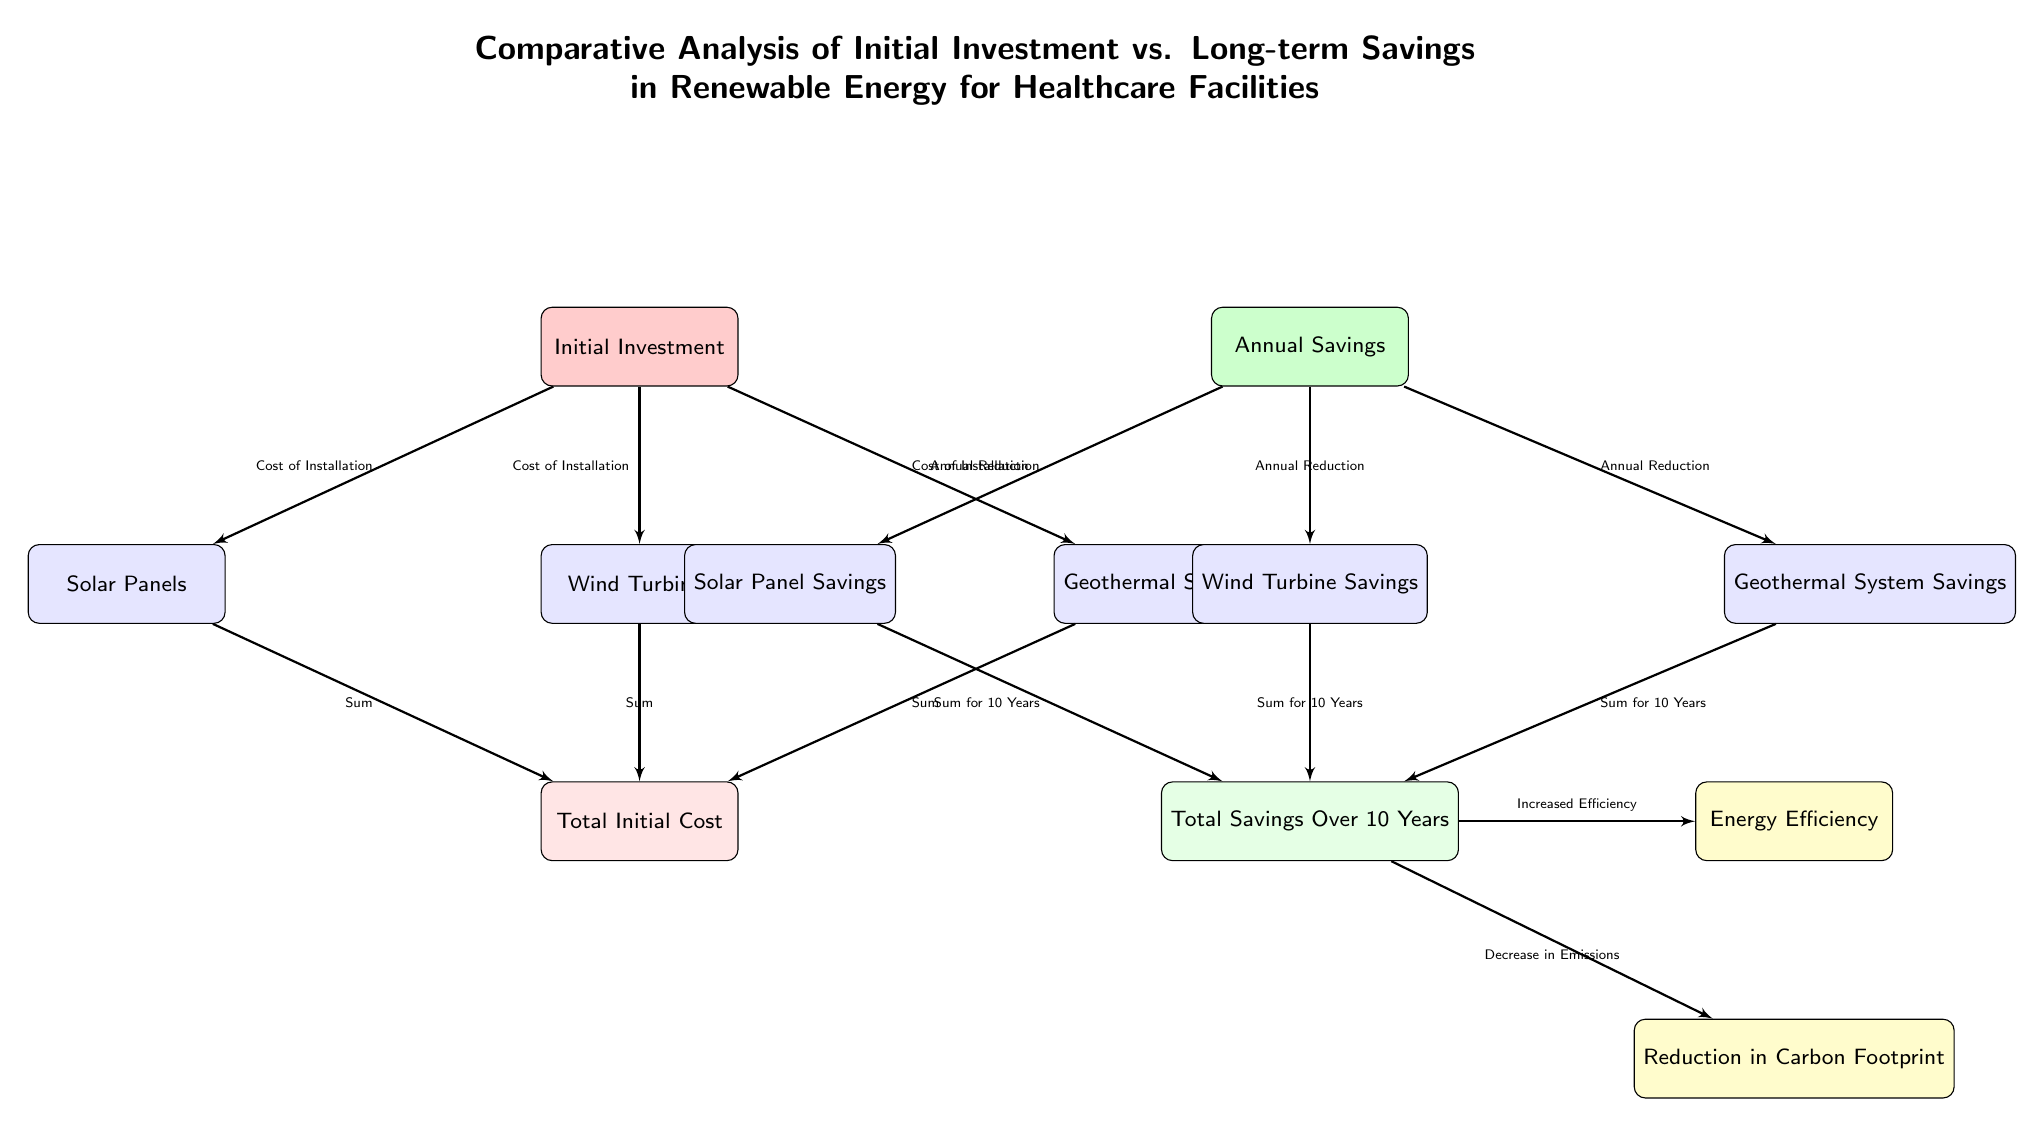What is the purpose of the diagram? The diagram presents a comparative analysis highlighting the initial investment versus long-term savings associated with renewable energy systems in healthcare facilities. It showcases different renewable energy sources and their financial impacts over a decade.
Answer: Comparative analysis of initial investment vs. long-term savings How many types of renewable energy systems are shown? The diagram displays three types of renewable energy systems: Solar Panels, Wind Turbines, and Geothermal Systems, which are visually represented below the Initial Investment node.
Answer: Three What color represents Annual Savings in the diagram? The Annual Savings section is filled with green, indicating the financial benefits gained over time from investing in renewable energy systems.
Answer: Green What does the arrow from Total Savings Over 10 Years point to? The arrow from Total Savings Over 10 Years points to two outcomes: Energy Efficiency and Reduction in Carbon Footprint, showing the resulting benefits of the accumulated savings.
Answer: Energy Efficiency and Reduction in Carbon Footprint What type of relationship is illustrated between the Initial Investment and the savings? A causal relationship is depicted where the Initial Investment in renewable energy systems leads to Annual Savings, which accumulates to long-term benefits over a ten-year span.
Answer: Causal relationship How is Total Initial Cost calculated? Total Initial Cost is calculated by summing the costs associated with each renewable energy source: Solar Panels, Wind Turbines, and Geothermal Systems, as shown by the connecting arrows.
Answer: Sum of installation costs What outcome arises from the Total Savings Over 10 Years? The Total Savings Over 10 Years leads to two outcomes: increased energy efficiency and a decrease in emissions, which emphasize the environmental benefits alongside financial savings.
Answer: Increased Efficiency and Decrease in Emissions What does the diagram imply about carbon emissions? The diagram implies that investing in renewable energy systems results in a reduction of carbon emissions, as indicated by the connection to the carbon footprint reduction outcome.
Answer: Reduction in Carbon Footprint How is Total Savings Over 10 Years determined from Annual Savings? Total Savings Over 10 Years is determined by summing the annual savings from each type of renewable energy system over the entire decade, illustrating the cumulative effect.
Answer: Sum for 10 Years 